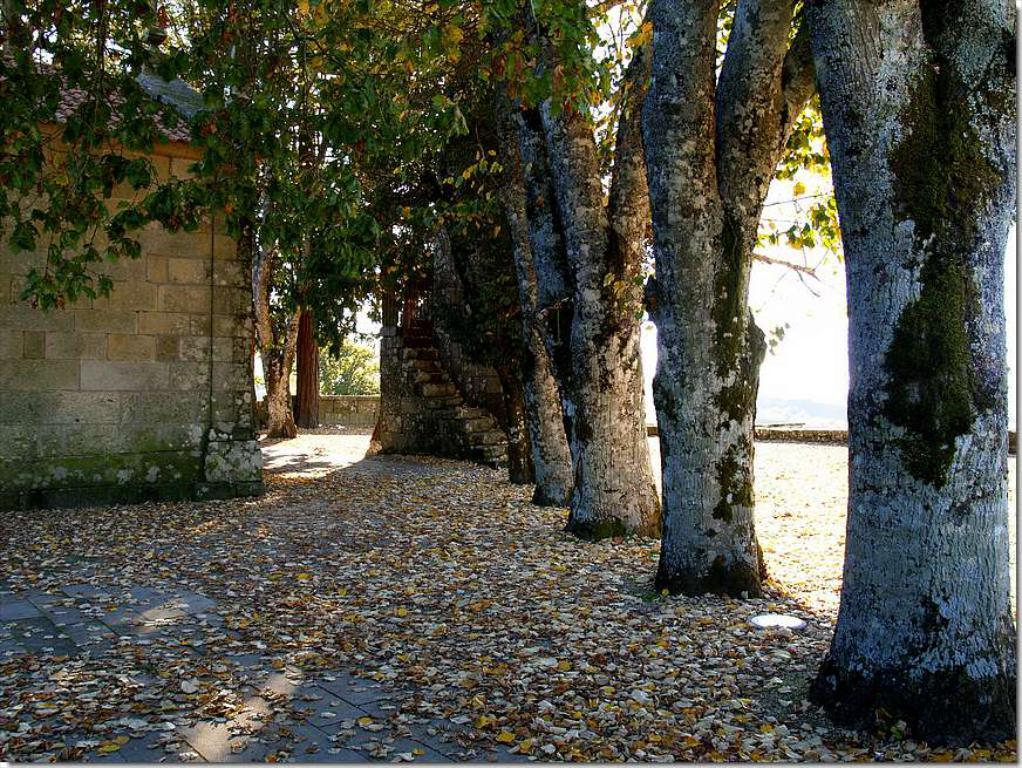What type of vegetation can be seen in the image? There are trees in the image. What type of structure is present in the image? There is a house in the image. What is covering the ground in the image? The ground is visible in the image and has dried leaves. What is visible in the background of the image? The sky is visible in the image. Where is the tub located in the image? There is no tub present in the image. What type of quiver can be seen hanging on the trees in the image? There is no quiver present in the image; it only features trees and a house. 